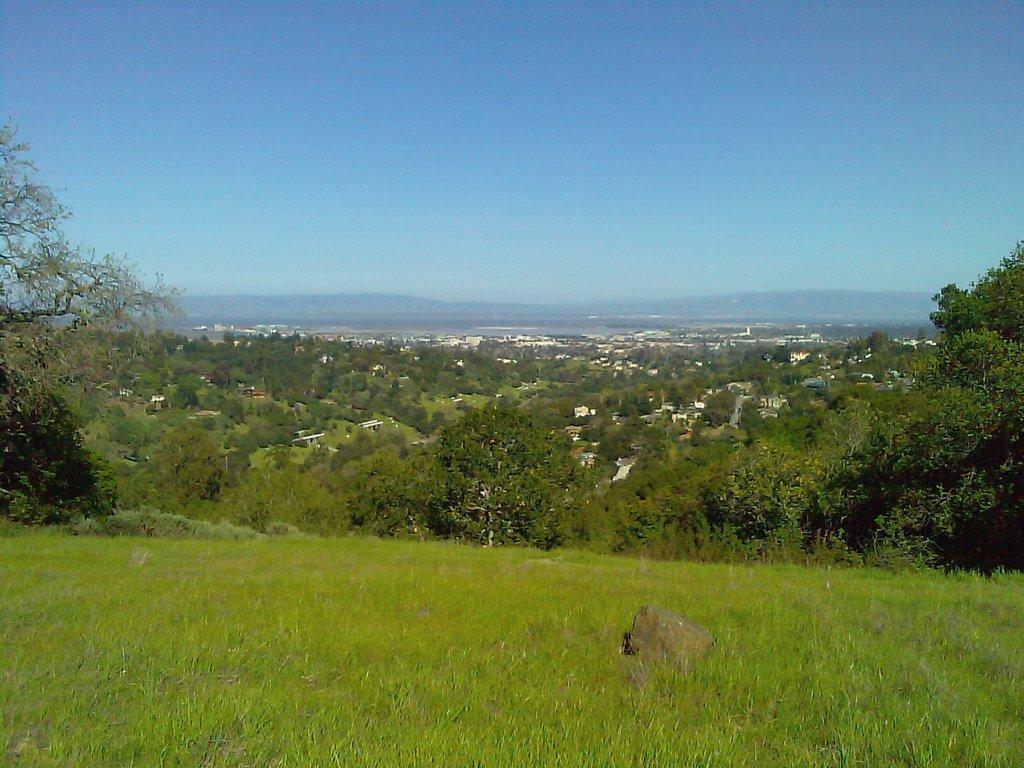Can you describe this image briefly? At the bottom of the image there is grass. In the background there are tree and buildings. At the top there is sky. 